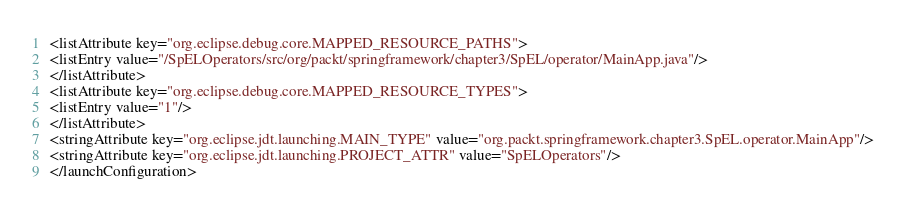<code> <loc_0><loc_0><loc_500><loc_500><_XML_><listAttribute key="org.eclipse.debug.core.MAPPED_RESOURCE_PATHS">
<listEntry value="/SpELOperators/src/org/packt/springframework/chapter3/SpEL/operator/MainApp.java"/>
</listAttribute>
<listAttribute key="org.eclipse.debug.core.MAPPED_RESOURCE_TYPES">
<listEntry value="1"/>
</listAttribute>
<stringAttribute key="org.eclipse.jdt.launching.MAIN_TYPE" value="org.packt.springframework.chapter3.SpEL.operator.MainApp"/>
<stringAttribute key="org.eclipse.jdt.launching.PROJECT_ATTR" value="SpELOperators"/>
</launchConfiguration>
</code> 